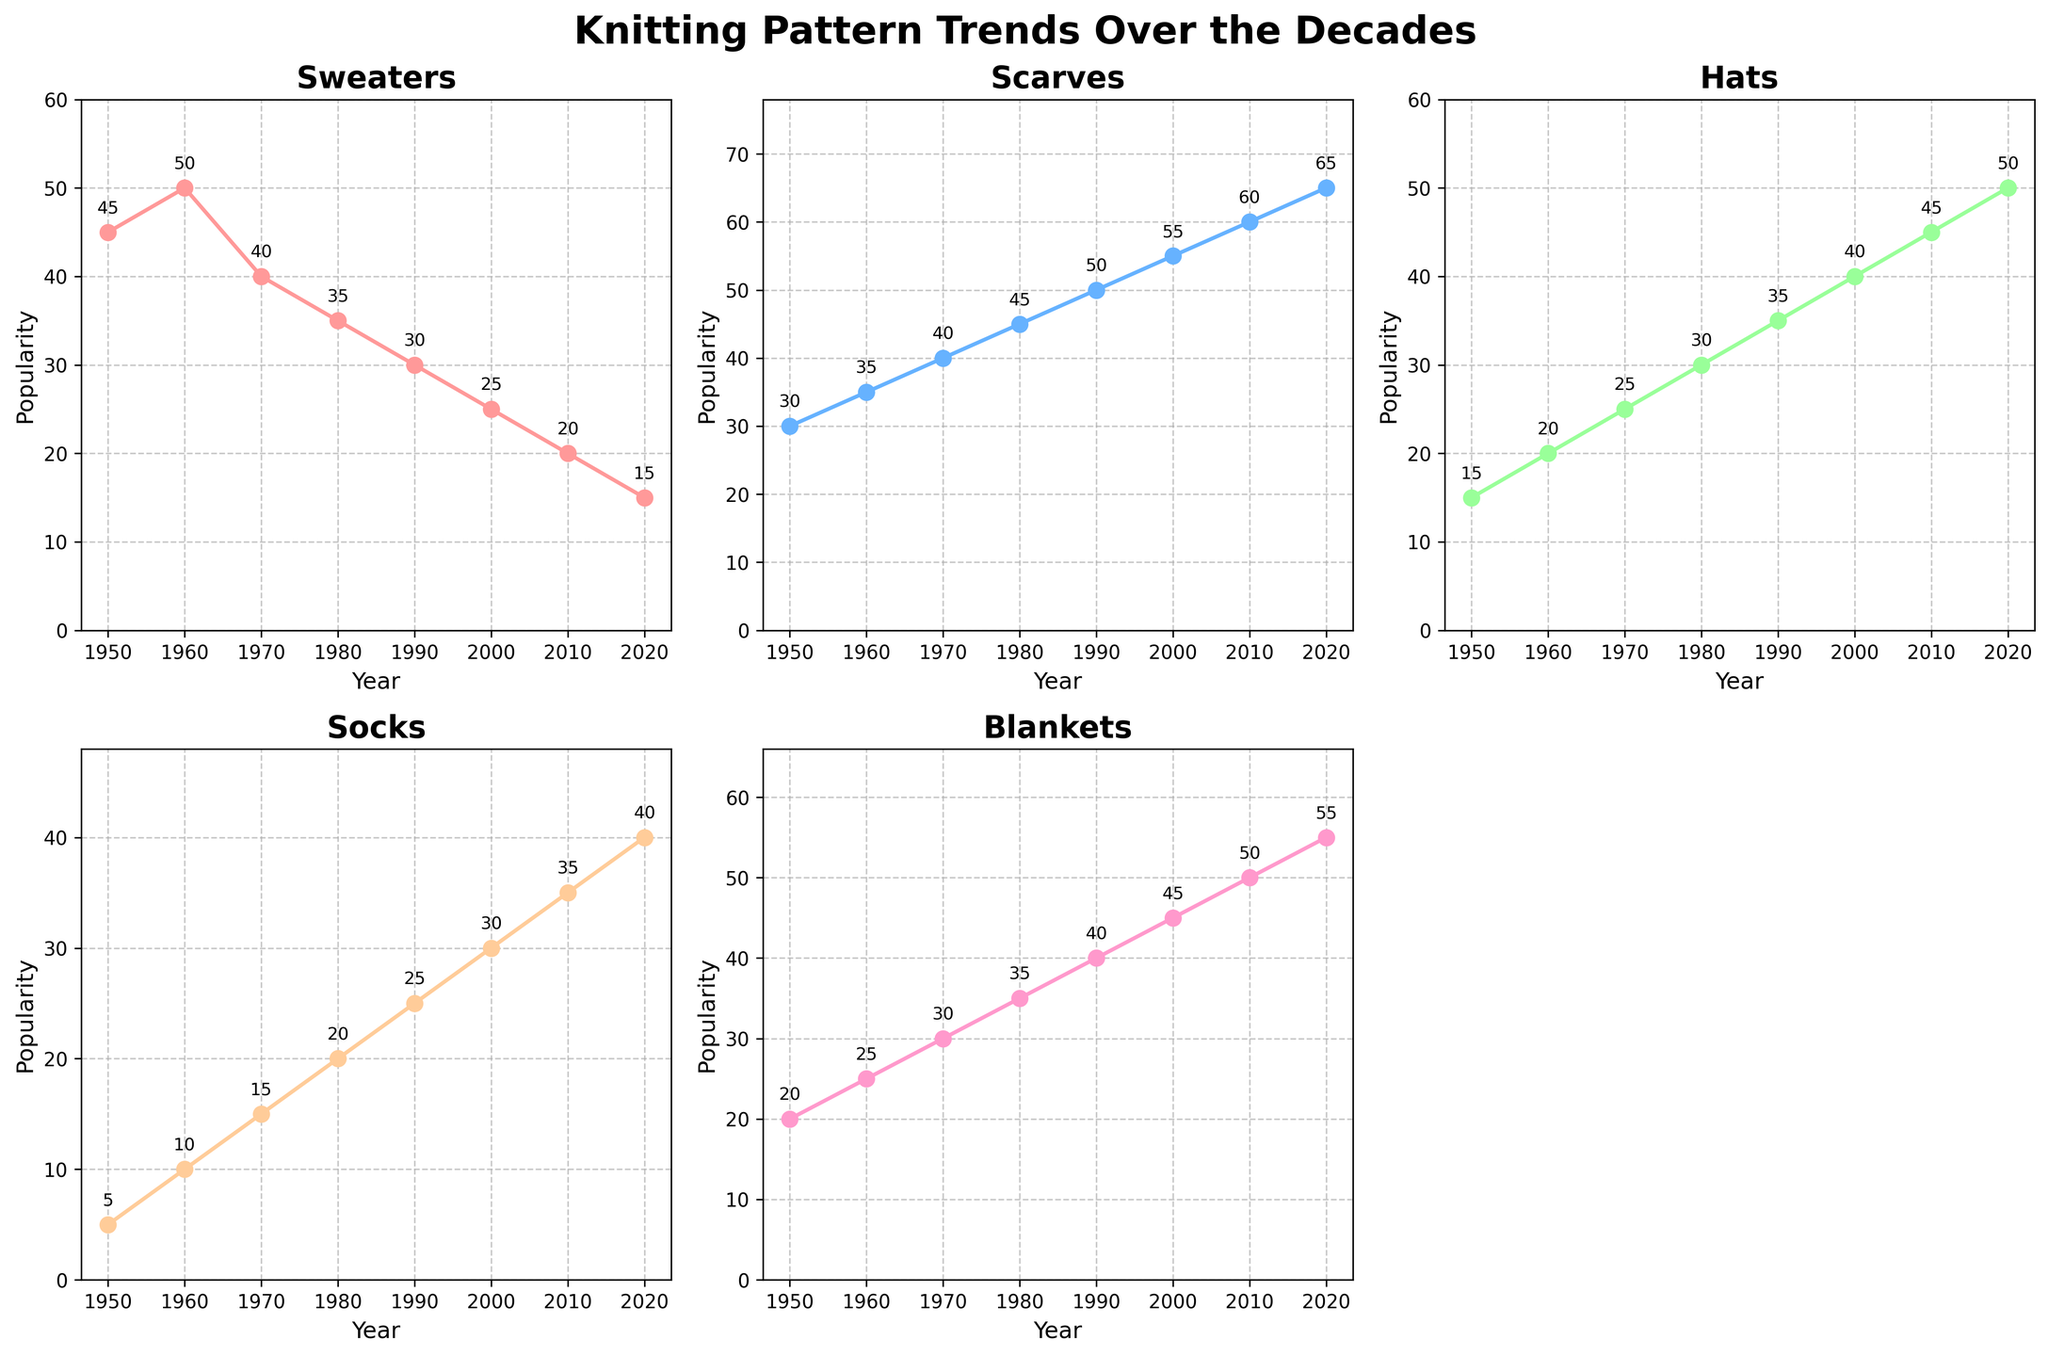What's the trend of popularity for Sweaters from 1950 to 2020? The plot for Sweaters shows a decreasing trend over the decades. The line starts at 45 in 1950 and steadily drops to 15 in 2020. The markers on the line decrease in height with each subsequent decade.
Answer: Decreasing Which garment type had the highest popularity in 2000? The plots show that Blankets had the highest popularity in 2000 with a value of 45. This is higher than the other garment types for the same year.
Answer: Blankets Compare the popularity of Scarves and Socks in 1990. Which was more popular? In 1990, the plot for Scarves shows a value of 50, while the plot for Socks shows a value of 25. Since 50 is greater than 25, Scarves were more popular in 1990.
Answer: Scarves What was the second most popular garment type in 2020? In 2020, the plots show that the popularity values were: Sweaters (15), Scarves (65), Hats (50), Socks (40), Blankets (55). Sorting these, the second highest value is for Blankets at 55.
Answer: Blankets What's the average popularity of Hats over the decades from 1950 to 2020? The popularity values for Hats from 1950 to 2020 are 15, 20, 25, 30, 35, 40, 45, 50. Summing these values gives 260. There are 8 data points, so the average is 260/8 = 32.5.
Answer: 32.5 Which garment type shows a consistent increase in popularity over the decades? By examining each plot, it's clear that Scarves show a consistent increase in popularity from 30 in 1950 to 65 in 2020. The line for Scarves moves steadily upward without any decrease.
Answer: Scarves How much more popular were Blankets than Sweaters in 2010? In 2010, the popularity of Blankets was 50 and Sweaters was 20. Subtracting these values, 50 - 20, gives the difference of 30.
Answer: 30 Compare the visual height of the popularity markers for Hats across decades. Do they show an increasing, decreasing, or no clear trend? The markers for Hats show an increasing trend in their height. Starting from 15 in 1950 and rising to 50 in 2020, the markers increase in height with each decade.
Answer: Increasing What is the difference in the popularity of Scarves between 1960 and 1990? In 1960, Scarves had a popularity of 35, and in 1990, it was 50. The difference is 50 - 35 = 15.
Answer: 15 